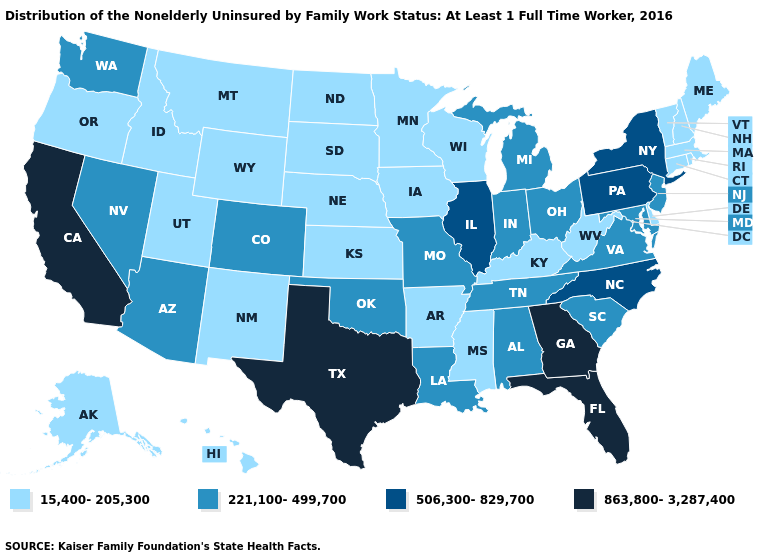What is the lowest value in the MidWest?
Quick response, please. 15,400-205,300. What is the value of Kentucky?
Give a very brief answer. 15,400-205,300. What is the value of Kentucky?
Quick response, please. 15,400-205,300. Which states hav the highest value in the MidWest?
Write a very short answer. Illinois. What is the lowest value in the MidWest?
Write a very short answer. 15,400-205,300. Name the states that have a value in the range 221,100-499,700?
Give a very brief answer. Alabama, Arizona, Colorado, Indiana, Louisiana, Maryland, Michigan, Missouri, Nevada, New Jersey, Ohio, Oklahoma, South Carolina, Tennessee, Virginia, Washington. Name the states that have a value in the range 15,400-205,300?
Keep it brief. Alaska, Arkansas, Connecticut, Delaware, Hawaii, Idaho, Iowa, Kansas, Kentucky, Maine, Massachusetts, Minnesota, Mississippi, Montana, Nebraska, New Hampshire, New Mexico, North Dakota, Oregon, Rhode Island, South Dakota, Utah, Vermont, West Virginia, Wisconsin, Wyoming. What is the value of Maine?
Be succinct. 15,400-205,300. Name the states that have a value in the range 15,400-205,300?
Give a very brief answer. Alaska, Arkansas, Connecticut, Delaware, Hawaii, Idaho, Iowa, Kansas, Kentucky, Maine, Massachusetts, Minnesota, Mississippi, Montana, Nebraska, New Hampshire, New Mexico, North Dakota, Oregon, Rhode Island, South Dakota, Utah, Vermont, West Virginia, Wisconsin, Wyoming. Among the states that border Massachusetts , does New York have the lowest value?
Answer briefly. No. Name the states that have a value in the range 221,100-499,700?
Answer briefly. Alabama, Arizona, Colorado, Indiana, Louisiana, Maryland, Michigan, Missouri, Nevada, New Jersey, Ohio, Oklahoma, South Carolina, Tennessee, Virginia, Washington. Among the states that border Colorado , does Kansas have the lowest value?
Quick response, please. Yes. Among the states that border New Hampshire , which have the lowest value?
Be succinct. Maine, Massachusetts, Vermont. Does Oregon have the highest value in the USA?
Write a very short answer. No. Does South Dakota have the same value as North Dakota?
Answer briefly. Yes. 